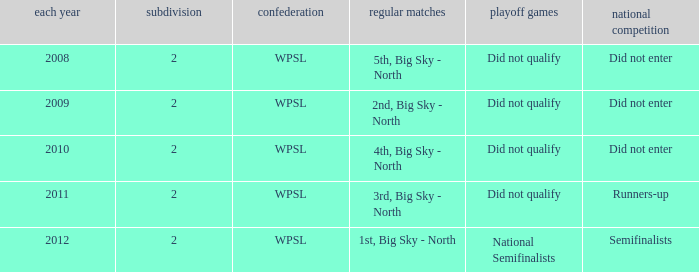What league was involved in 2008? WPSL. 